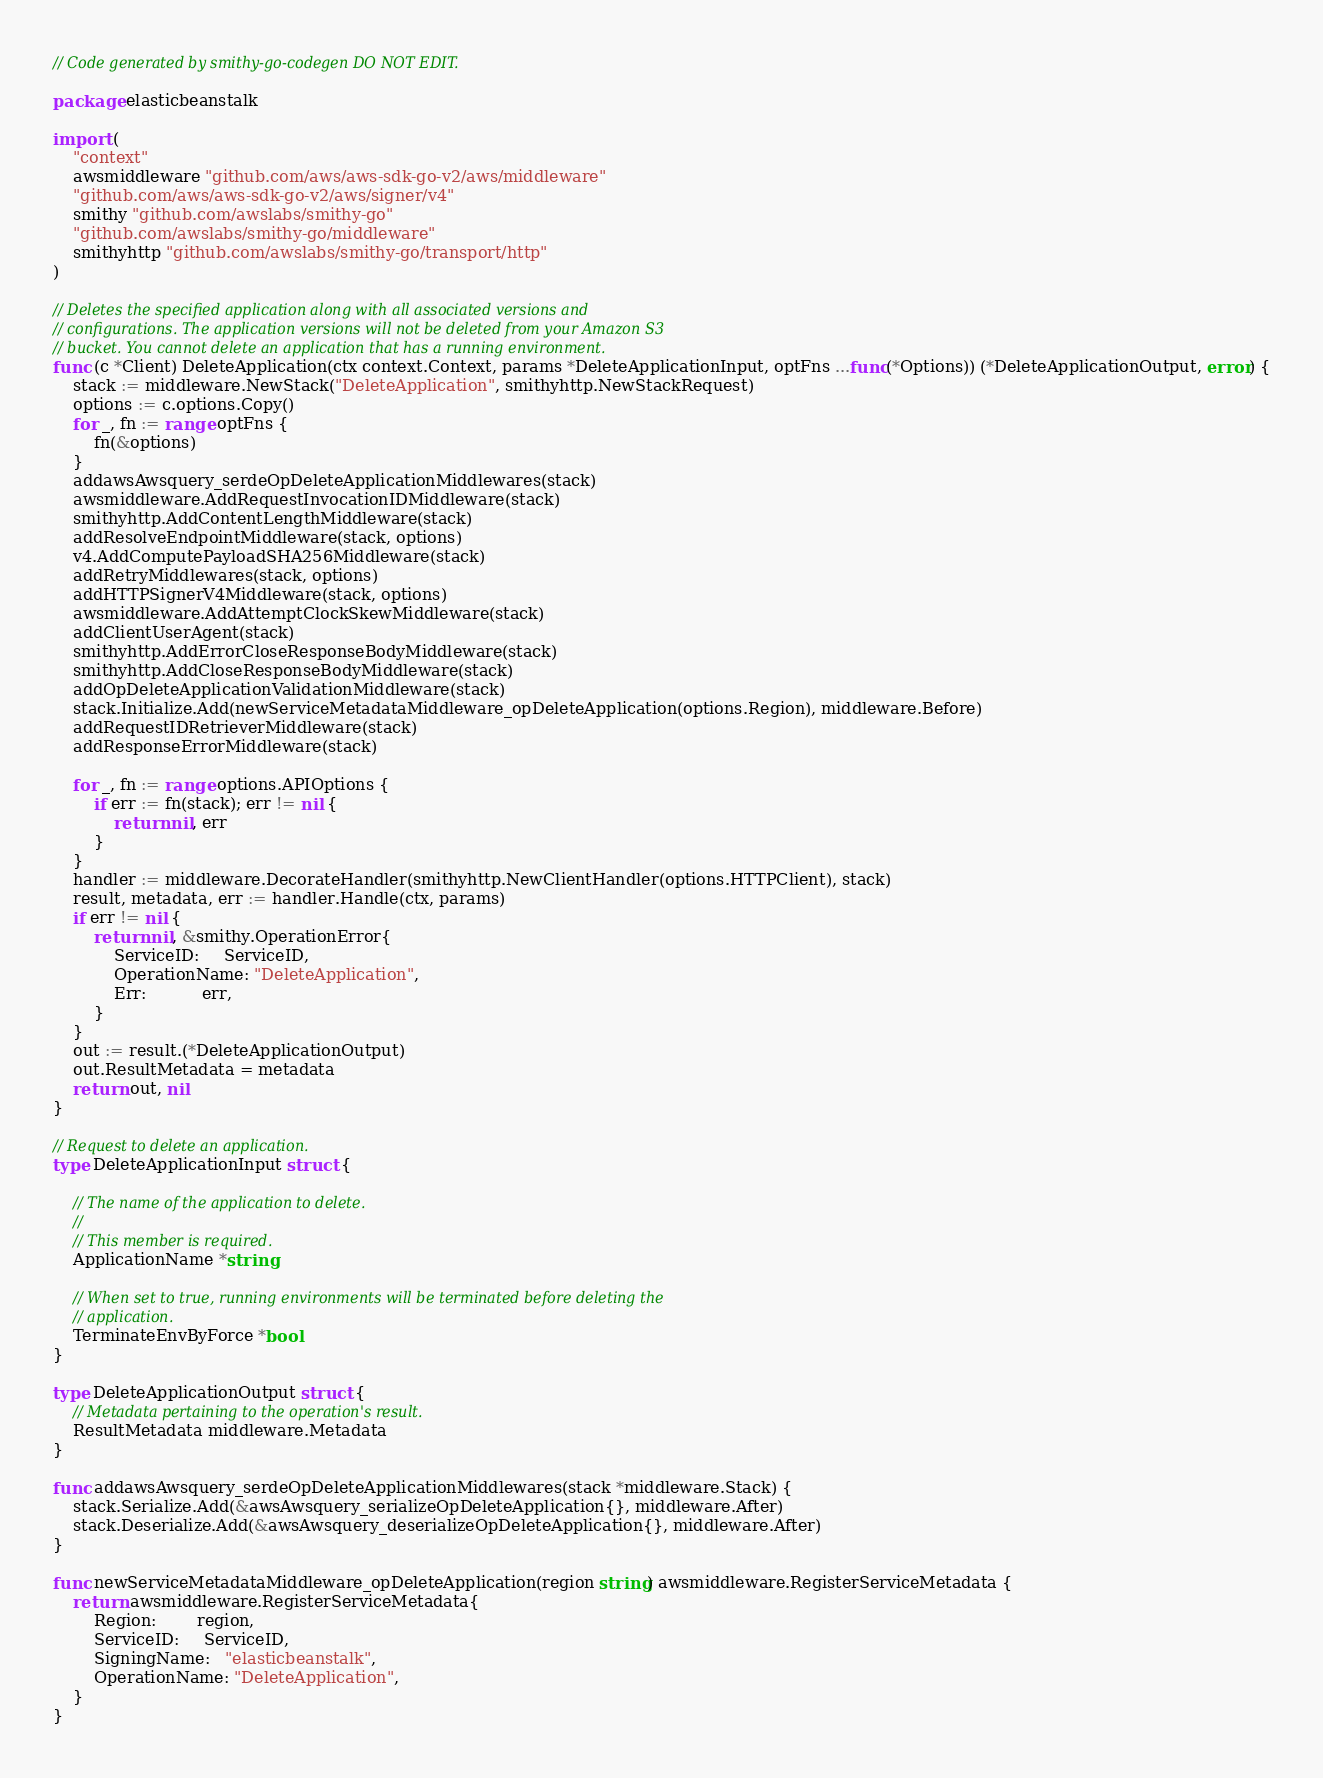<code> <loc_0><loc_0><loc_500><loc_500><_Go_>// Code generated by smithy-go-codegen DO NOT EDIT.

package elasticbeanstalk

import (
	"context"
	awsmiddleware "github.com/aws/aws-sdk-go-v2/aws/middleware"
	"github.com/aws/aws-sdk-go-v2/aws/signer/v4"
	smithy "github.com/awslabs/smithy-go"
	"github.com/awslabs/smithy-go/middleware"
	smithyhttp "github.com/awslabs/smithy-go/transport/http"
)

// Deletes the specified application along with all associated versions and
// configurations. The application versions will not be deleted from your Amazon S3
// bucket. You cannot delete an application that has a running environment.
func (c *Client) DeleteApplication(ctx context.Context, params *DeleteApplicationInput, optFns ...func(*Options)) (*DeleteApplicationOutput, error) {
	stack := middleware.NewStack("DeleteApplication", smithyhttp.NewStackRequest)
	options := c.options.Copy()
	for _, fn := range optFns {
		fn(&options)
	}
	addawsAwsquery_serdeOpDeleteApplicationMiddlewares(stack)
	awsmiddleware.AddRequestInvocationIDMiddleware(stack)
	smithyhttp.AddContentLengthMiddleware(stack)
	addResolveEndpointMiddleware(stack, options)
	v4.AddComputePayloadSHA256Middleware(stack)
	addRetryMiddlewares(stack, options)
	addHTTPSignerV4Middleware(stack, options)
	awsmiddleware.AddAttemptClockSkewMiddleware(stack)
	addClientUserAgent(stack)
	smithyhttp.AddErrorCloseResponseBodyMiddleware(stack)
	smithyhttp.AddCloseResponseBodyMiddleware(stack)
	addOpDeleteApplicationValidationMiddleware(stack)
	stack.Initialize.Add(newServiceMetadataMiddleware_opDeleteApplication(options.Region), middleware.Before)
	addRequestIDRetrieverMiddleware(stack)
	addResponseErrorMiddleware(stack)

	for _, fn := range options.APIOptions {
		if err := fn(stack); err != nil {
			return nil, err
		}
	}
	handler := middleware.DecorateHandler(smithyhttp.NewClientHandler(options.HTTPClient), stack)
	result, metadata, err := handler.Handle(ctx, params)
	if err != nil {
		return nil, &smithy.OperationError{
			ServiceID:     ServiceID,
			OperationName: "DeleteApplication",
			Err:           err,
		}
	}
	out := result.(*DeleteApplicationOutput)
	out.ResultMetadata = metadata
	return out, nil
}

// Request to delete an application.
type DeleteApplicationInput struct {

	// The name of the application to delete.
	//
	// This member is required.
	ApplicationName *string

	// When set to true, running environments will be terminated before deleting the
	// application.
	TerminateEnvByForce *bool
}

type DeleteApplicationOutput struct {
	// Metadata pertaining to the operation's result.
	ResultMetadata middleware.Metadata
}

func addawsAwsquery_serdeOpDeleteApplicationMiddlewares(stack *middleware.Stack) {
	stack.Serialize.Add(&awsAwsquery_serializeOpDeleteApplication{}, middleware.After)
	stack.Deserialize.Add(&awsAwsquery_deserializeOpDeleteApplication{}, middleware.After)
}

func newServiceMetadataMiddleware_opDeleteApplication(region string) awsmiddleware.RegisterServiceMetadata {
	return awsmiddleware.RegisterServiceMetadata{
		Region:        region,
		ServiceID:     ServiceID,
		SigningName:   "elasticbeanstalk",
		OperationName: "DeleteApplication",
	}
}
</code> 